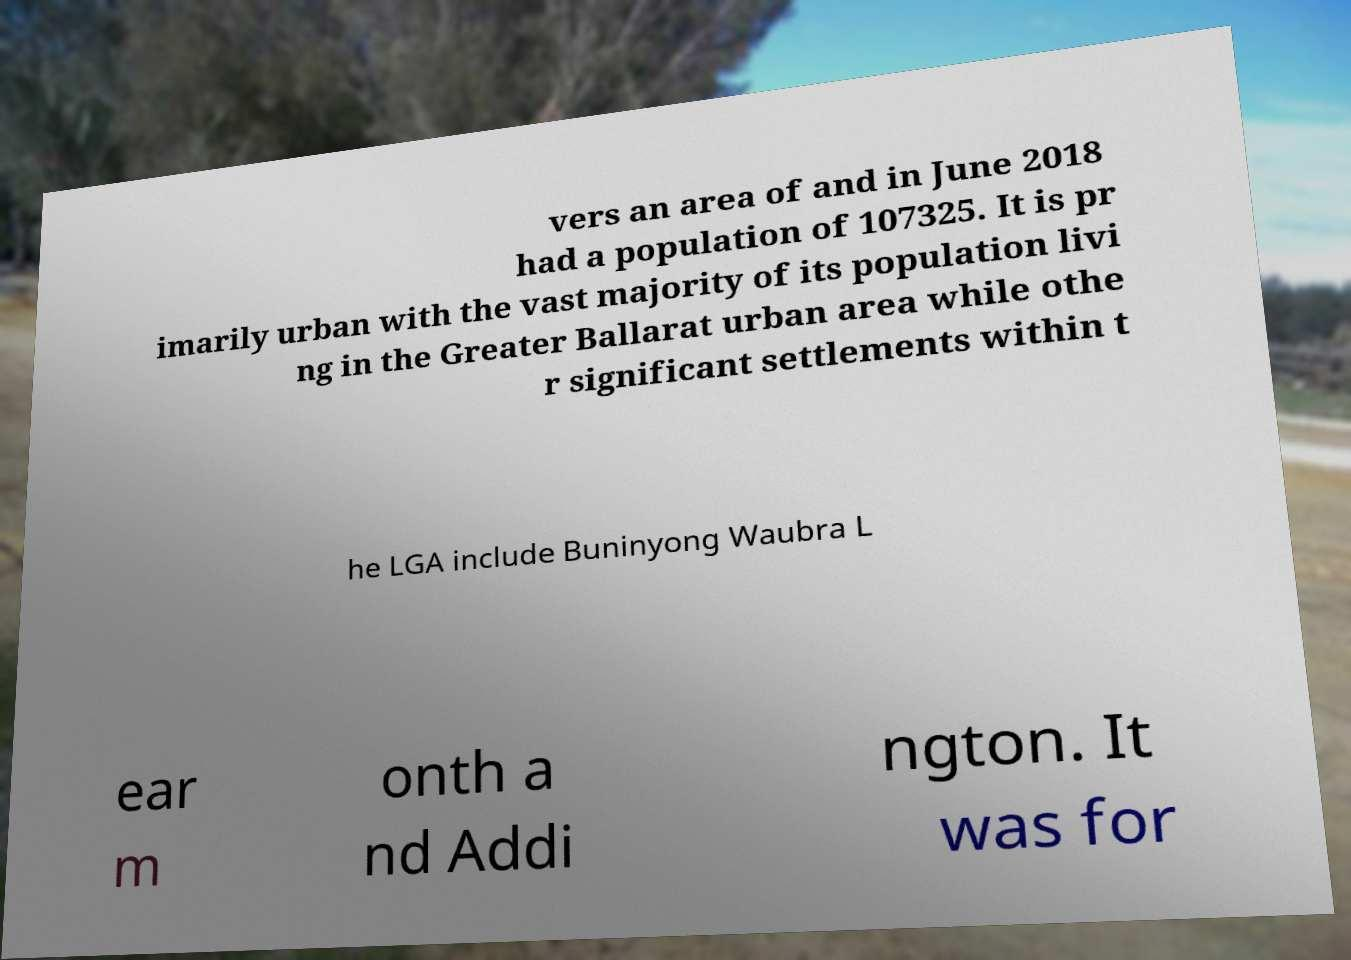For documentation purposes, I need the text within this image transcribed. Could you provide that? vers an area of and in June 2018 had a population of 107325. It is pr imarily urban with the vast majority of its population livi ng in the Greater Ballarat urban area while othe r significant settlements within t he LGA include Buninyong Waubra L ear m onth a nd Addi ngton. It was for 